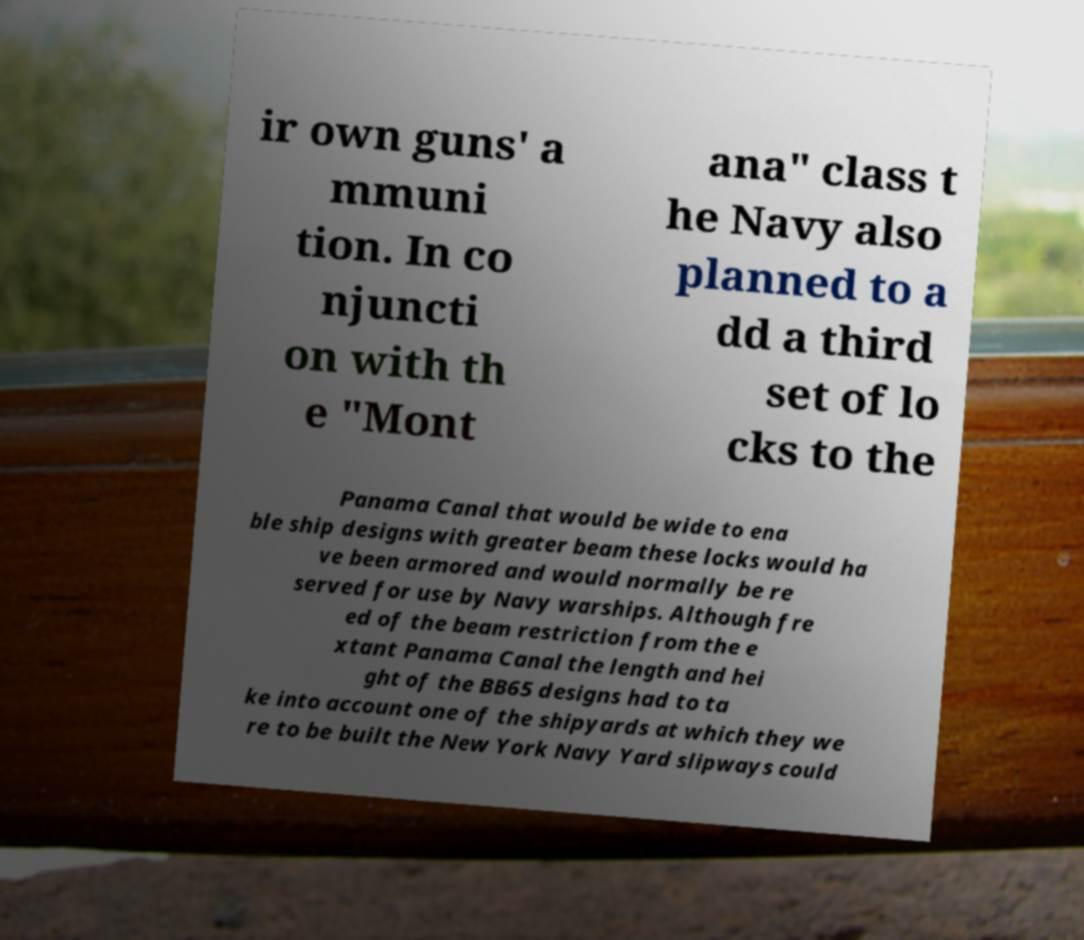Can you read and provide the text displayed in the image?This photo seems to have some interesting text. Can you extract and type it out for me? ir own guns' a mmuni tion. In co njuncti on with th e "Mont ana" class t he Navy also planned to a dd a third set of lo cks to the Panama Canal that would be wide to ena ble ship designs with greater beam these locks would ha ve been armored and would normally be re served for use by Navy warships. Although fre ed of the beam restriction from the e xtant Panama Canal the length and hei ght of the BB65 designs had to ta ke into account one of the shipyards at which they we re to be built the New York Navy Yard slipways could 